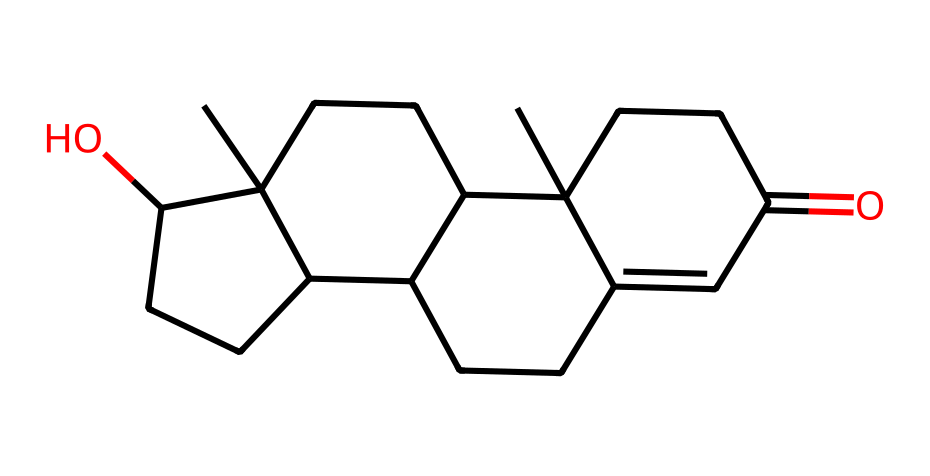What is the molecular formula of testosterone? To determine the molecular formula, we can break down the SMILES representation and count the number of each type of atom. The structure includes carbon (C), hydrogen (H), and oxygen (O). Upon analyzing the SMILES, we find 19 carbons, 28 hydrogens, and 2 oxygens. Consequently, the molecular formula is C19H28O2.
Answer: C19H28O2 How many rings are present in testosterone? By examining the chemical structure encoded in the SMILES, we note that the notation indicates the presence of multiple cyclic structures. The notation suggests that there are 4 distinct ring systems in the testosterone molecule. Therefore, the answer is four.
Answer: 4 Which functional groups are present in testosterone? In the SMILES representation, look for specific atoms or patterns that signify functional groups. In testosterone, we identify an alcohol group (due to the presence of the -OH group) and a ketone group (indicated by the =O). Thus, the functional groups present are hydroxyl and ketone.
Answer: hydroxyl, ketone What is the stereochemistry of testosterone based on its structure? Stereochemistry can be inferred from the arrangement of atoms and bonds in the chemical structure. In testosterone, there are chiral centers that create stereoisomers. By evaluating the structure and recognizing the specific chiral centers, we conclude that testosterone has multiple stereochemical configurations, indicating it is a steroid with specific stereochemical orientation. Therefore, we describe it as having multiple stereocenters.
Answer: multiple stereocenters What type of chemical is testosterone categorized as? Based on its structure and functional groups, testosterone is part of the steroid hormone category. Analyzing its molecular structure reveals characteristics typical of steroids, such as multiple fused rings and specific functional groups. Hence, the answer is steroid.
Answer: steroid 